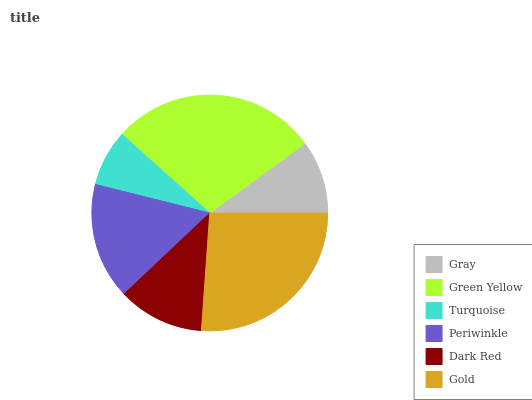Is Turquoise the minimum?
Answer yes or no. Yes. Is Green Yellow the maximum?
Answer yes or no. Yes. Is Green Yellow the minimum?
Answer yes or no. No. Is Turquoise the maximum?
Answer yes or no. No. Is Green Yellow greater than Turquoise?
Answer yes or no. Yes. Is Turquoise less than Green Yellow?
Answer yes or no. Yes. Is Turquoise greater than Green Yellow?
Answer yes or no. No. Is Green Yellow less than Turquoise?
Answer yes or no. No. Is Periwinkle the high median?
Answer yes or no. Yes. Is Dark Red the low median?
Answer yes or no. Yes. Is Gray the high median?
Answer yes or no. No. Is Gold the low median?
Answer yes or no. No. 